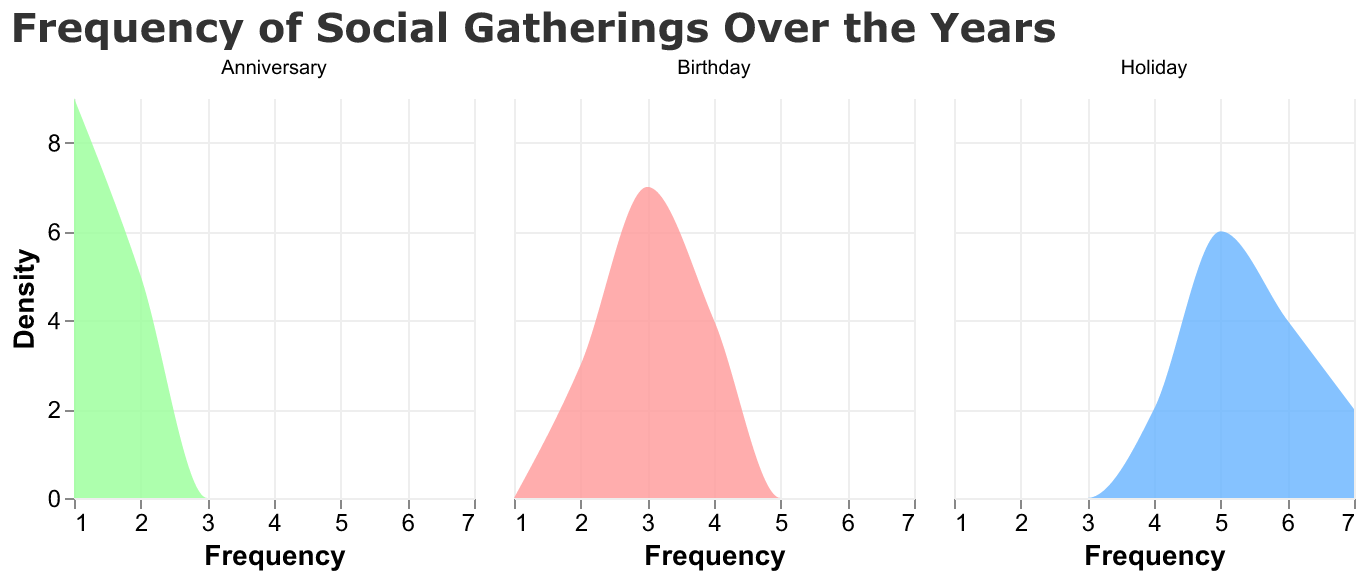Which event had the highest frequency of social gatherings in 2014? The figure shows three subplots for each type of event. By looking at the subplot for 2014, the line for "Holiday" reaches the highest density.
Answer: Holiday Which event had the lowest frequency of social gatherings across all years? Observing all subplots, "Anniversary" consistently has the lowest maximum density value compared to "Birthday" and "Holiday".
Answer: Anniversary When did social gatherings for birthdays reach their peak frequency? Looking at the subplot for "Birthday", the peak density value reaches its highest in the year 2014.
Answer: 2014 How does the frequency of holiday gatherings in 2023 compare to that in 2010? Comparing the two time points, the figure shows that the frequency of holiday gatherings in 2023 (higher peak value) is greater than in 2010.
Answer: 2023 is higher than 2010 What is the average frequency of holiday gatherings over all years? The subplot for "Holiday" shows peaks at various points. Sum the frequency values (5+4+6+5+7+5+6+5+4+6+5+7) for each year and divide by the number of years. (66/12)
Answer: 5.5 In which year did the number of social gatherings for anniversaries increase compared to previous years? For "Anniversary", comparing year to year, the density increased in the years 2012, 2014, 2017, 2021, and 2022 compared to their preceding years.
Answer: 2012, 2014, 2017, 2021, 2022 Do birthday gatherings show a consistent trend over the years? Analyzing the "Birthday" plot, there are fluctuations with no consistent increase or decrease trend over the given years.
Answer: No consistent trend Which year has the highest density for holiday gatherings? Among all the years in the "Holiday" subplot, 2014 and 2023 show the highest peaks, indicating the highest density.
Answer: 2014, 2023 What is the combined frequency of social gatherings for birthdays and holidays in 2015? For 2015, add the birthday frequency (3) to the holiday frequency (5).
Answer: 8 